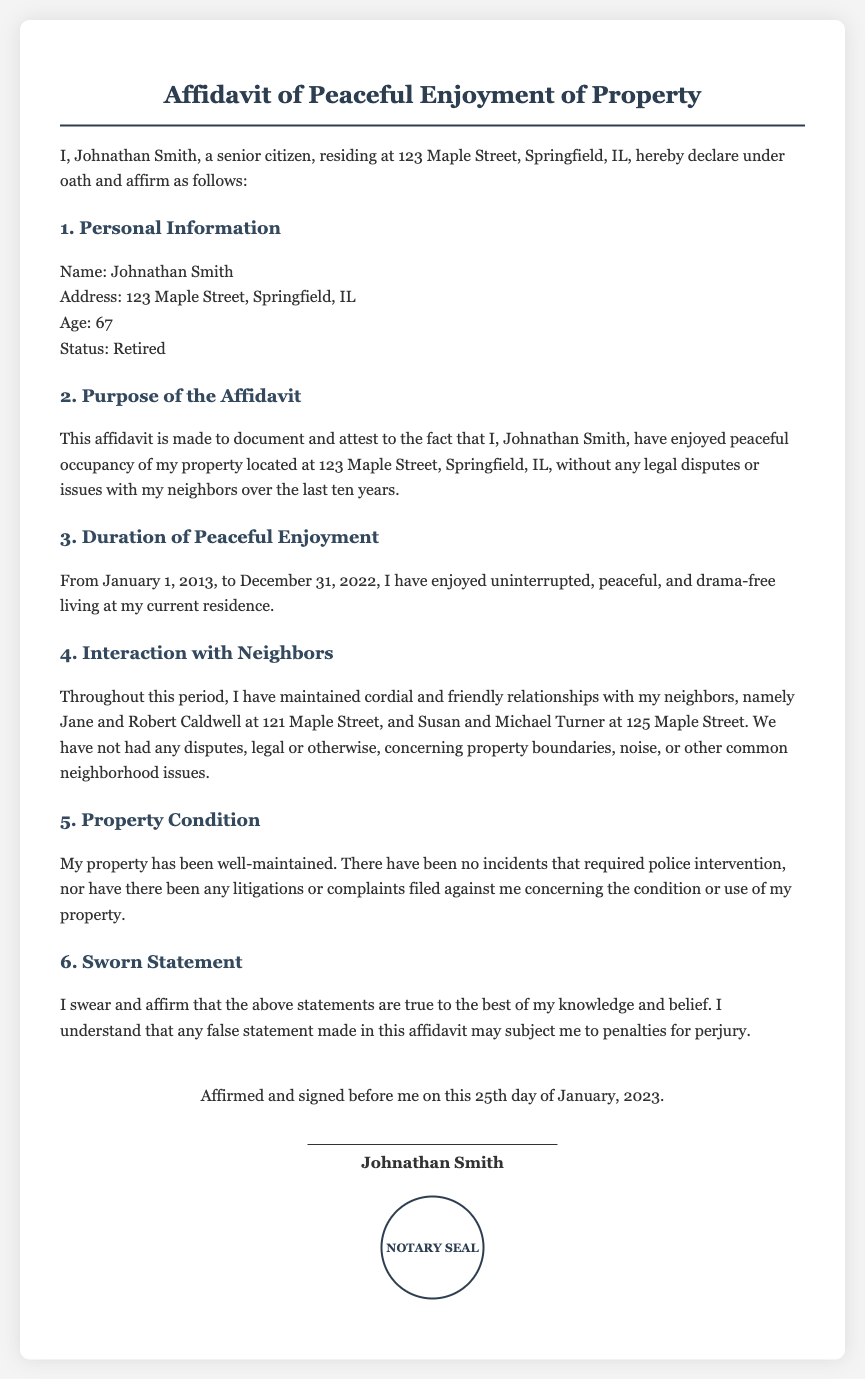What is the name of the person making the affidavit? The name of the person making the affidavit is explicitly stated in the introduction section of the document.
Answer: Johnathan Smith What is the age of Johnathan Smith? The age of Johnathan Smith is mentioned in the personal information section of the affidavit.
Answer: 67 What is the address of the property? The address of the property is included in the declaration at the beginning of the document.
Answer: 123 Maple Street, Springfield, IL What is the duration of peaceful enjoyment documented? The duration is defined within the affidavit, stating the specific period of peaceful enjoyment.
Answer: From January 1, 2013, to December 31, 2022 Who are Johnathan Smith's neighbors? The affidavit lists the neighbors to show the friendly relationships maintained during the stated period.
Answer: Jane and Robert Caldwell, Susan and Michael Turner Has there been any police intervention? This question pertains to the document's claims about the property condition and interactions in the neighborhood.
Answer: No What type of relationships has Johnathan Smith maintained with his neighbors? This is answered in the interaction section, indicating the nature of relationships within the community.
Answer: Cordial and friendly What is the purpose of the affidavit? The purpose is stated plainly in the document to clarify why it was created.
Answer: To document and attest to peaceful occupancy When was the affidavit affirmed and signed? The signing date is provided towards the end of the document for legal documentation purposes.
Answer: 25th day of January, 2023 